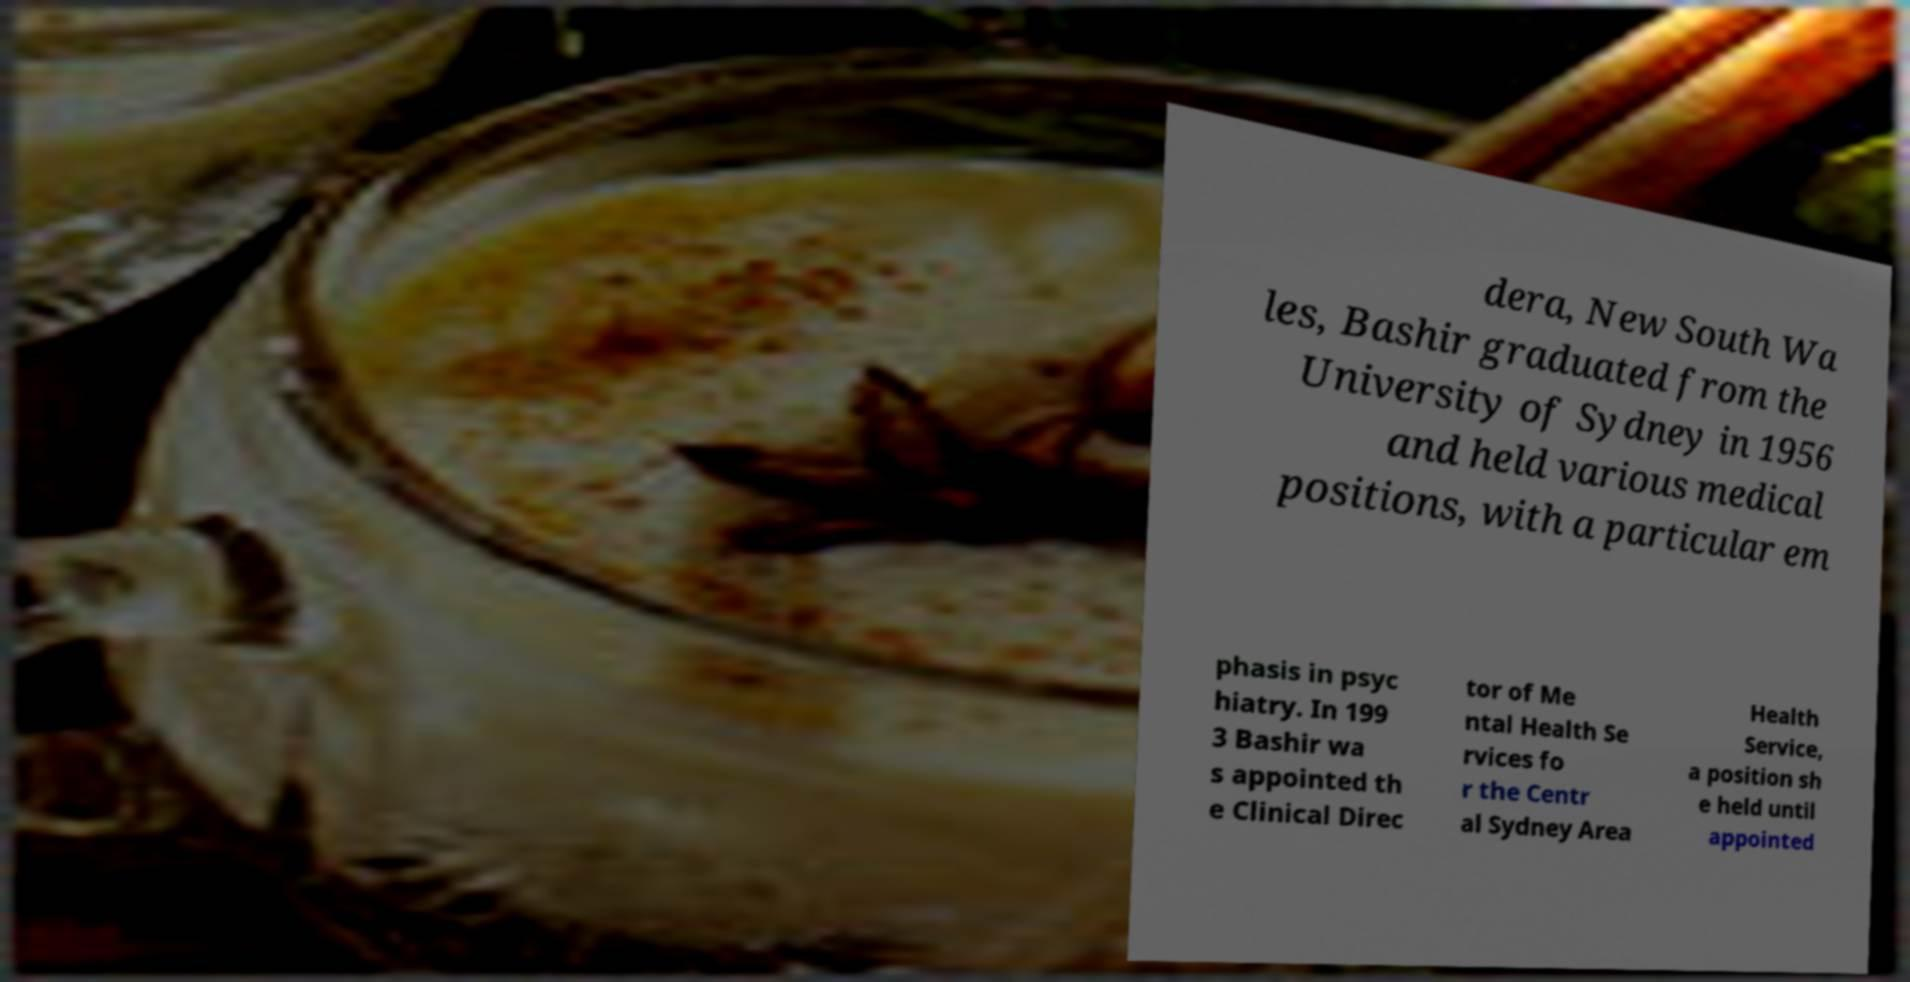Can you accurately transcribe the text from the provided image for me? dera, New South Wa les, Bashir graduated from the University of Sydney in 1956 and held various medical positions, with a particular em phasis in psyc hiatry. In 199 3 Bashir wa s appointed th e Clinical Direc tor of Me ntal Health Se rvices fo r the Centr al Sydney Area Health Service, a position sh e held until appointed 